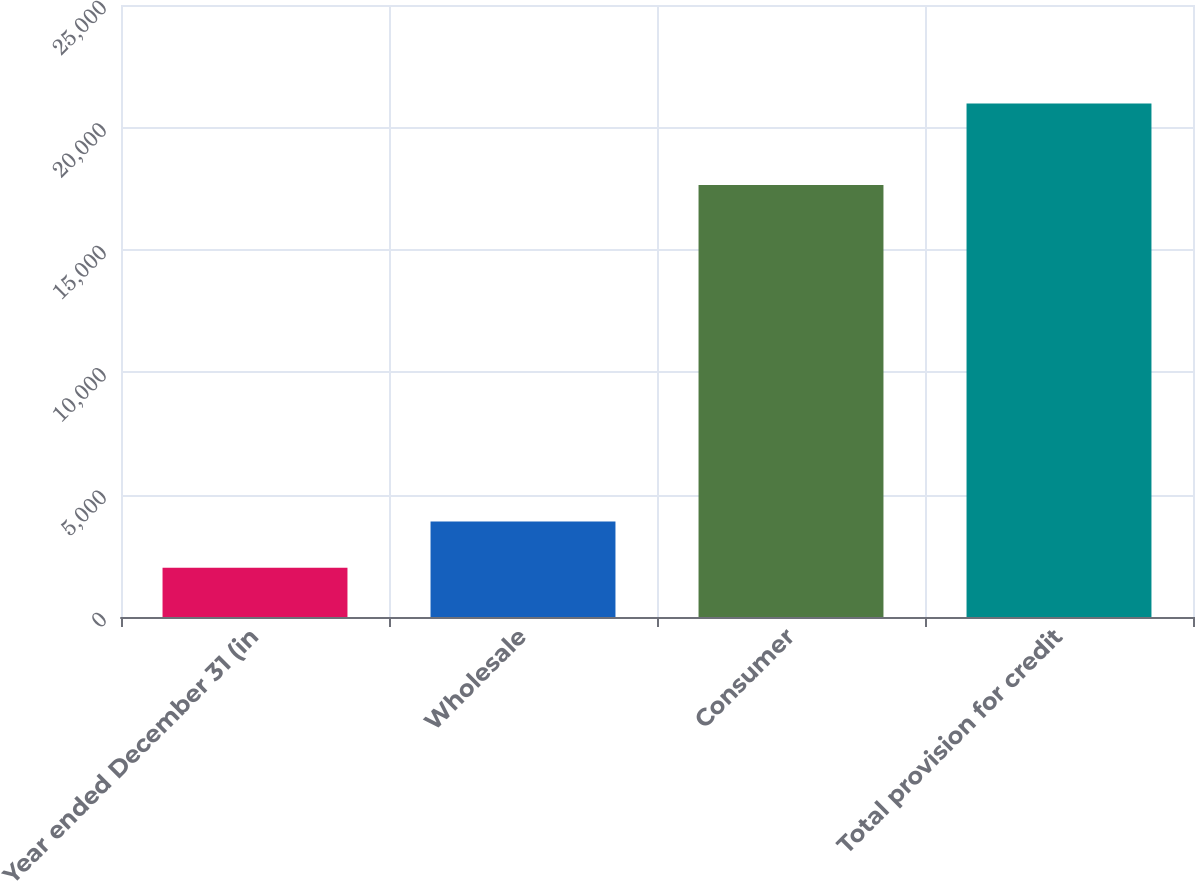<chart> <loc_0><loc_0><loc_500><loc_500><bar_chart><fcel>Year ended December 31 (in<fcel>Wholesale<fcel>Consumer<fcel>Total provision for credit<nl><fcel>2008<fcel>3905.1<fcel>17652<fcel>20979<nl></chart> 